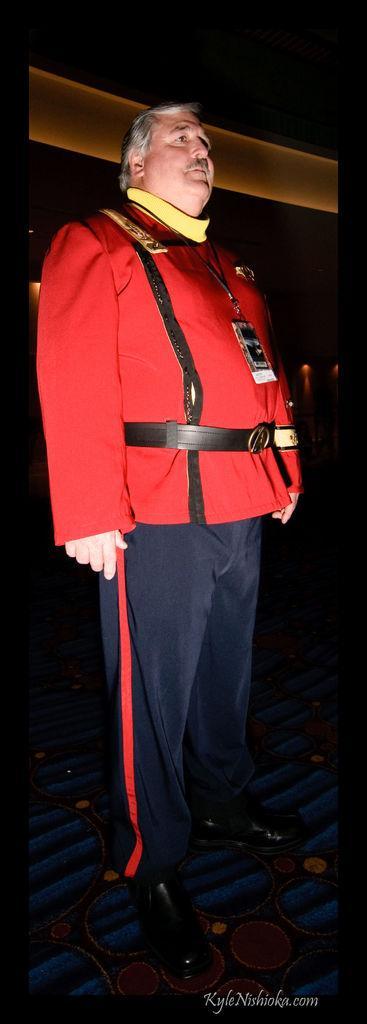How would you summarize this image in a sentence or two? In this image there is a man standing, he is wearing an identity card, there is a carpet on the floor, there is the wall behind the man, there is text towards the bottom of the image. 